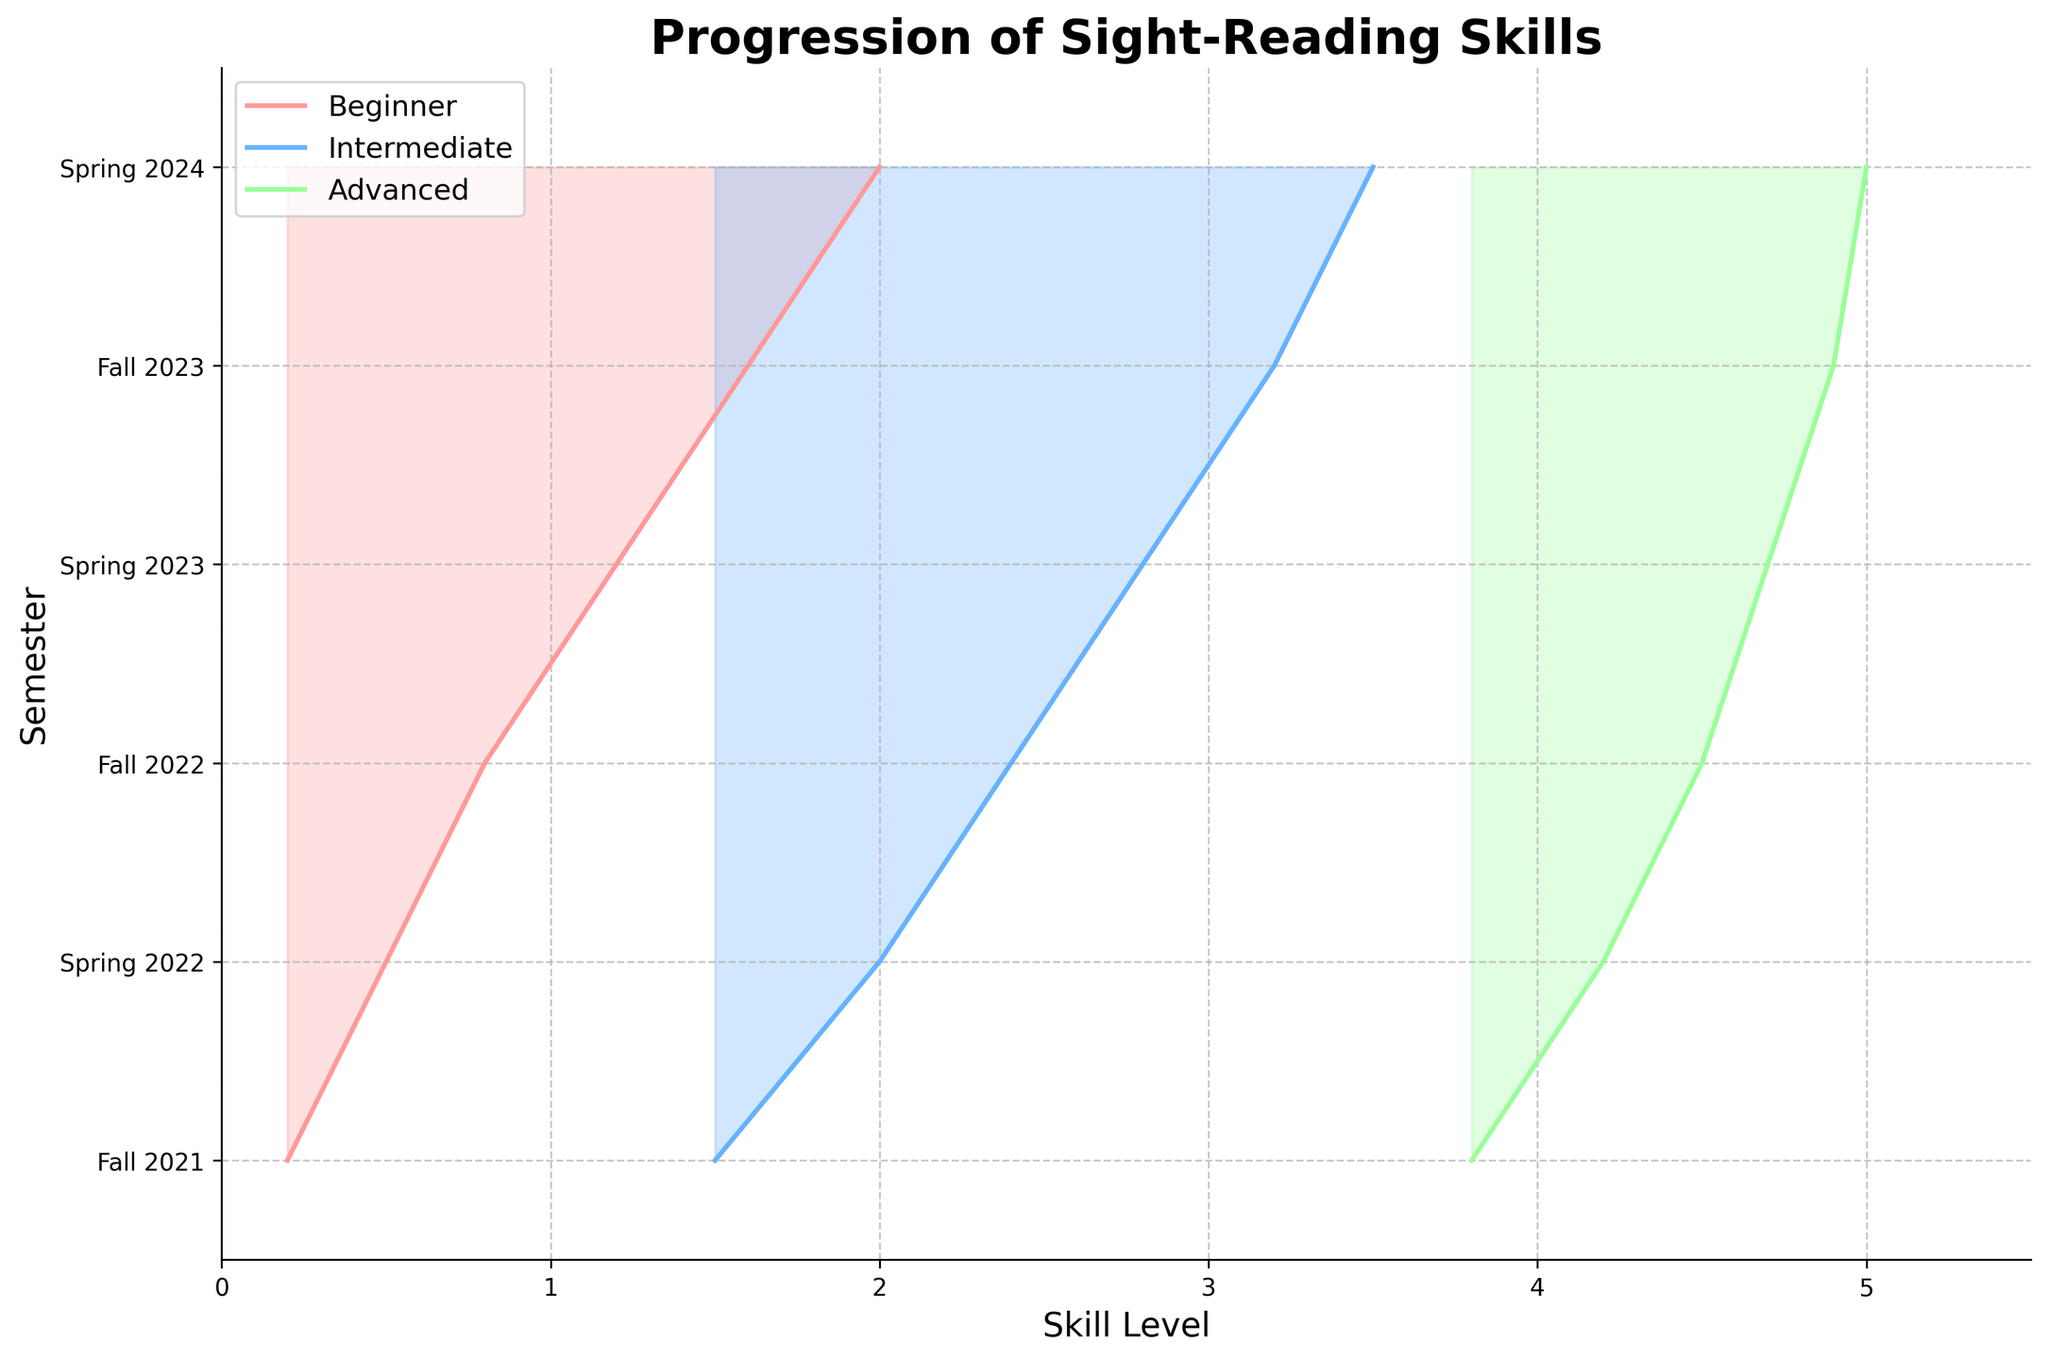What's the title of the plot? Look at the top of the figure where titles are usually situated. The title here is a textual description summarizing the plot.
Answer: Progression of Sight-Reading Skills What does the x-axis represent in this plot? The x-axis represents the skill level in the plot, indicated by the label 'Skill Level' along the horizontal axis.
Answer: Skill Level How many semesters are represented in the plot? Count the number of unique labels on the y-axis, each representing a different semester. There are six such labels.
Answer: 6 semesters Which skill level has the highest value in Spring 2024? Locate Spring 2024 on the y-axis, then find the highest point among the Beginner, Intermediate, and Advanced skill levels. Advanced is the highest, just above 5.0.
Answer: Advanced By how much did the Beginner skill level increase between Fall 2021 and Spring 2024? Find the Beginner skill levels at Fall 2021 and Spring 2024 (0.2 and 2.0 respectively). Calculate the difference: 2.0 - 0.2 = 1.8.
Answer: 1.8 Which skill level category shows the most consistent progression across all the semesters? Compare the trajectories of the Beginner, Intermediate, and Advanced lines. The Advanced line shows more consistent and steady progression with little fluctuation.
Answer: Advanced How does the Intermediate skill level in Fall 2023 compare to Fall 2022? Look at the Intermediate points for Fall 2022 and Fall 2023 on the plot. Intermediate skill level is 2.4 in Fall 2022 and 3.2 in Fall 2023, showing an increase.
Answer: Increased What is the overall trend in sight-reading skills for all categories over multiple semesters? Observe that all three categories (Beginner, Intermediate, Advanced) show an upward trend over time, indicating improvement in sight-reading skills across semesters.
Answer: Upward trend Which semester shows the largest increase in Advanced skill level compared to the previous semester? Calculate the differences in Advanced skill levels between consecutive semesters. The difference between Spring 2022 (4.2) and Fall 2021 (3.8) is 0.4, which is the largest increase among all semesters.
Answer: Spring 2022 